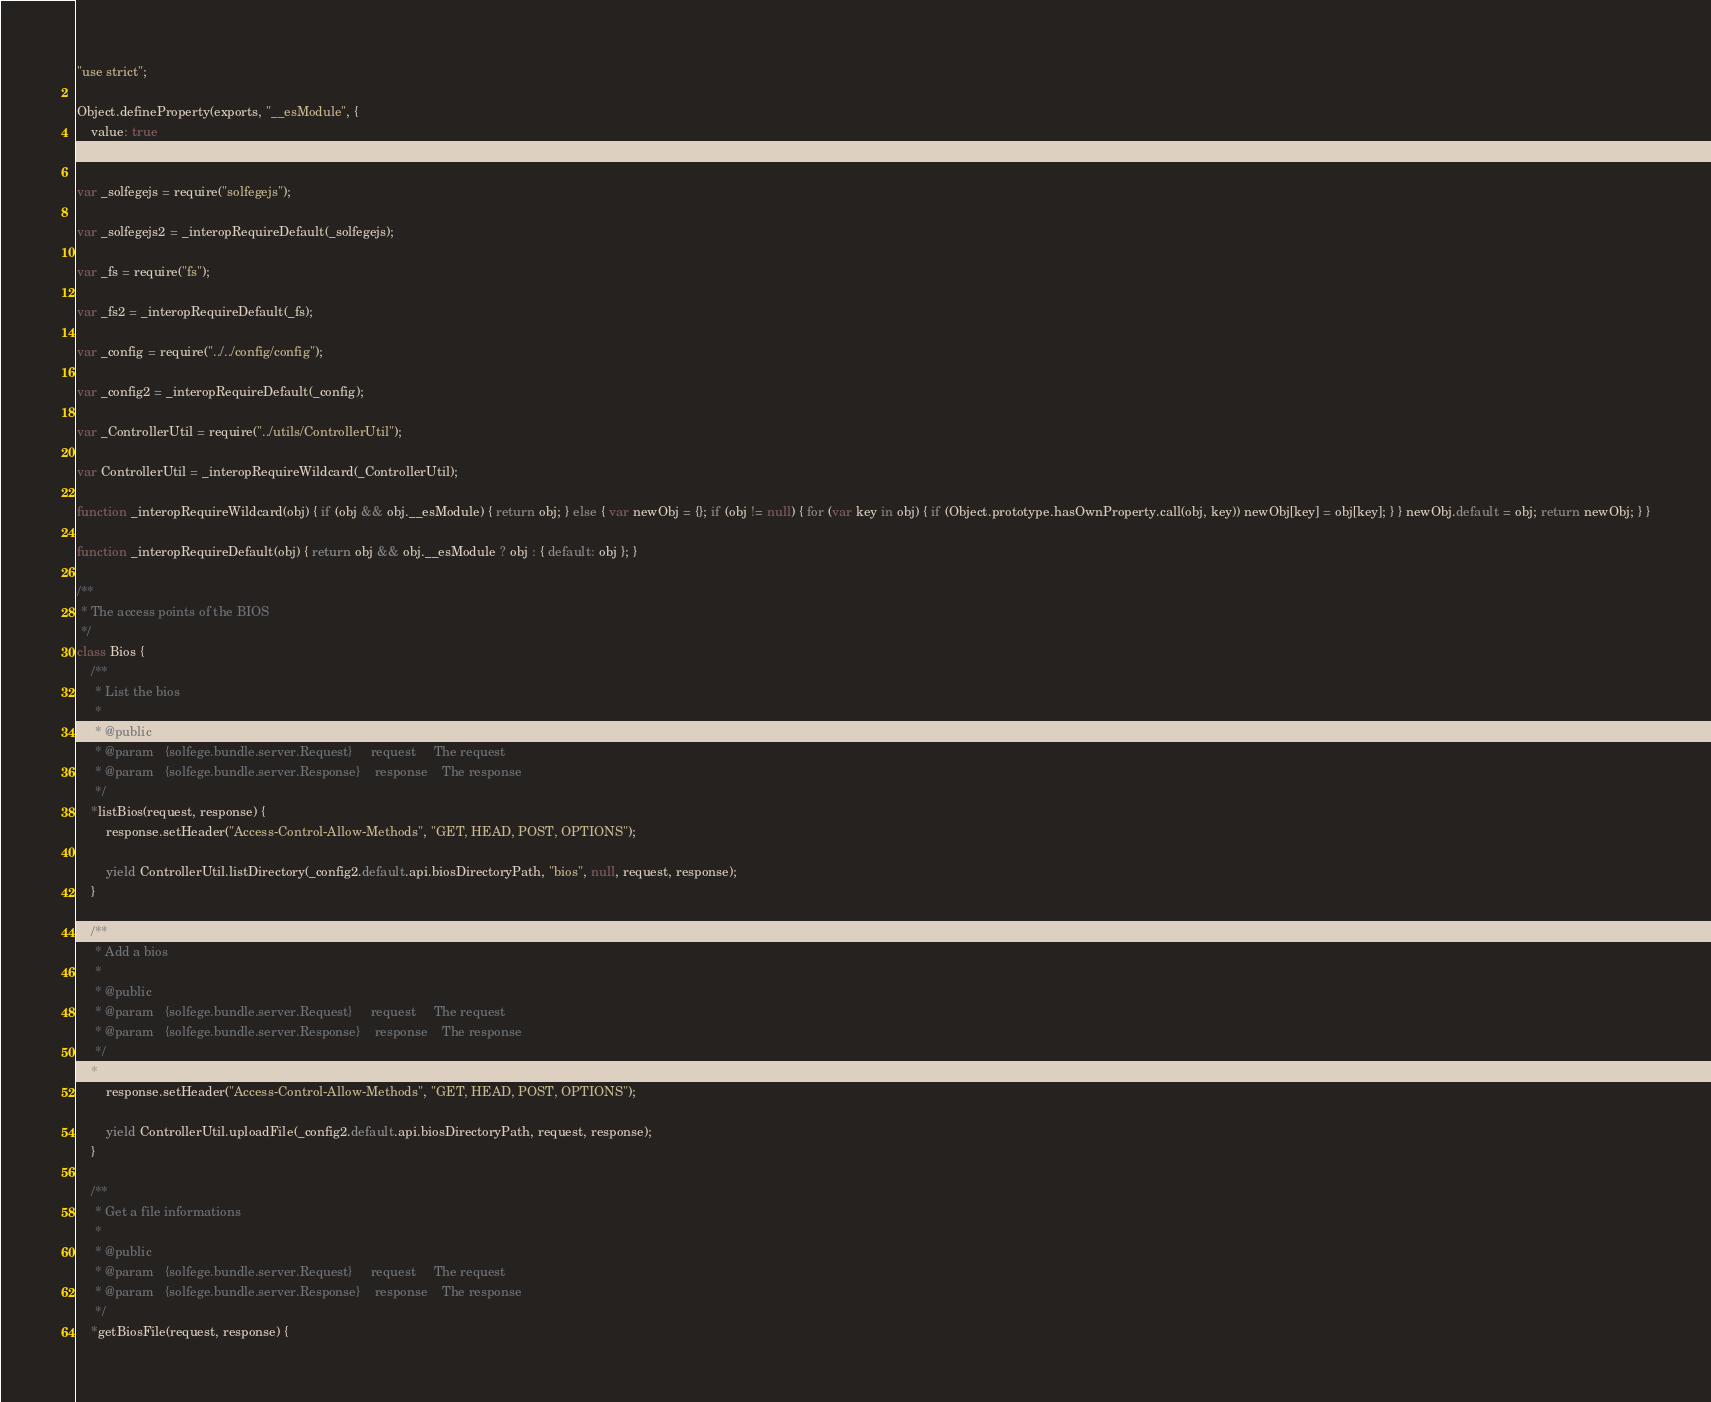Convert code to text. <code><loc_0><loc_0><loc_500><loc_500><_JavaScript_>"use strict";

Object.defineProperty(exports, "__esModule", {
    value: true
});

var _solfegejs = require("solfegejs");

var _solfegejs2 = _interopRequireDefault(_solfegejs);

var _fs = require("fs");

var _fs2 = _interopRequireDefault(_fs);

var _config = require("../../config/config");

var _config2 = _interopRequireDefault(_config);

var _ControllerUtil = require("../utils/ControllerUtil");

var ControllerUtil = _interopRequireWildcard(_ControllerUtil);

function _interopRequireWildcard(obj) { if (obj && obj.__esModule) { return obj; } else { var newObj = {}; if (obj != null) { for (var key in obj) { if (Object.prototype.hasOwnProperty.call(obj, key)) newObj[key] = obj[key]; } } newObj.default = obj; return newObj; } }

function _interopRequireDefault(obj) { return obj && obj.__esModule ? obj : { default: obj }; }

/**
 * The access points of the BIOS
 */
class Bios {
    /**
     * List the bios
     *
     * @public
     * @param   {solfege.bundle.server.Request}     request     The request
     * @param   {solfege.bundle.server.Response}    response    The response
     */
    *listBios(request, response) {
        response.setHeader("Access-Control-Allow-Methods", "GET, HEAD, POST, OPTIONS");

        yield ControllerUtil.listDirectory(_config2.default.api.biosDirectoryPath, "bios", null, request, response);
    }

    /**
     * Add a bios
     *
     * @public
     * @param   {solfege.bundle.server.Request}     request     The request
     * @param   {solfege.bundle.server.Response}    response    The response
     */
    *addBios(request, response) {
        response.setHeader("Access-Control-Allow-Methods", "GET, HEAD, POST, OPTIONS");

        yield ControllerUtil.uploadFile(_config2.default.api.biosDirectoryPath, request, response);
    }

    /**
     * Get a file informations
     *
     * @public
     * @param   {solfege.bundle.server.Request}     request     The request
     * @param   {solfege.bundle.server.Response}    response    The response
     */
    *getBiosFile(request, response) {</code> 